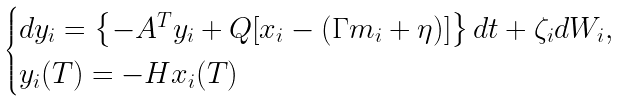<formula> <loc_0><loc_0><loc_500><loc_500>\begin{cases} d y _ { i } = \left \{ - A ^ { T } y _ { i } + Q [ x _ { i } - ( \Gamma m _ { i } + \eta ) ] \right \} d t + \zeta _ { i } d W _ { i } , \\ y _ { i } ( T ) = - H x _ { i } ( T ) \end{cases}</formula> 